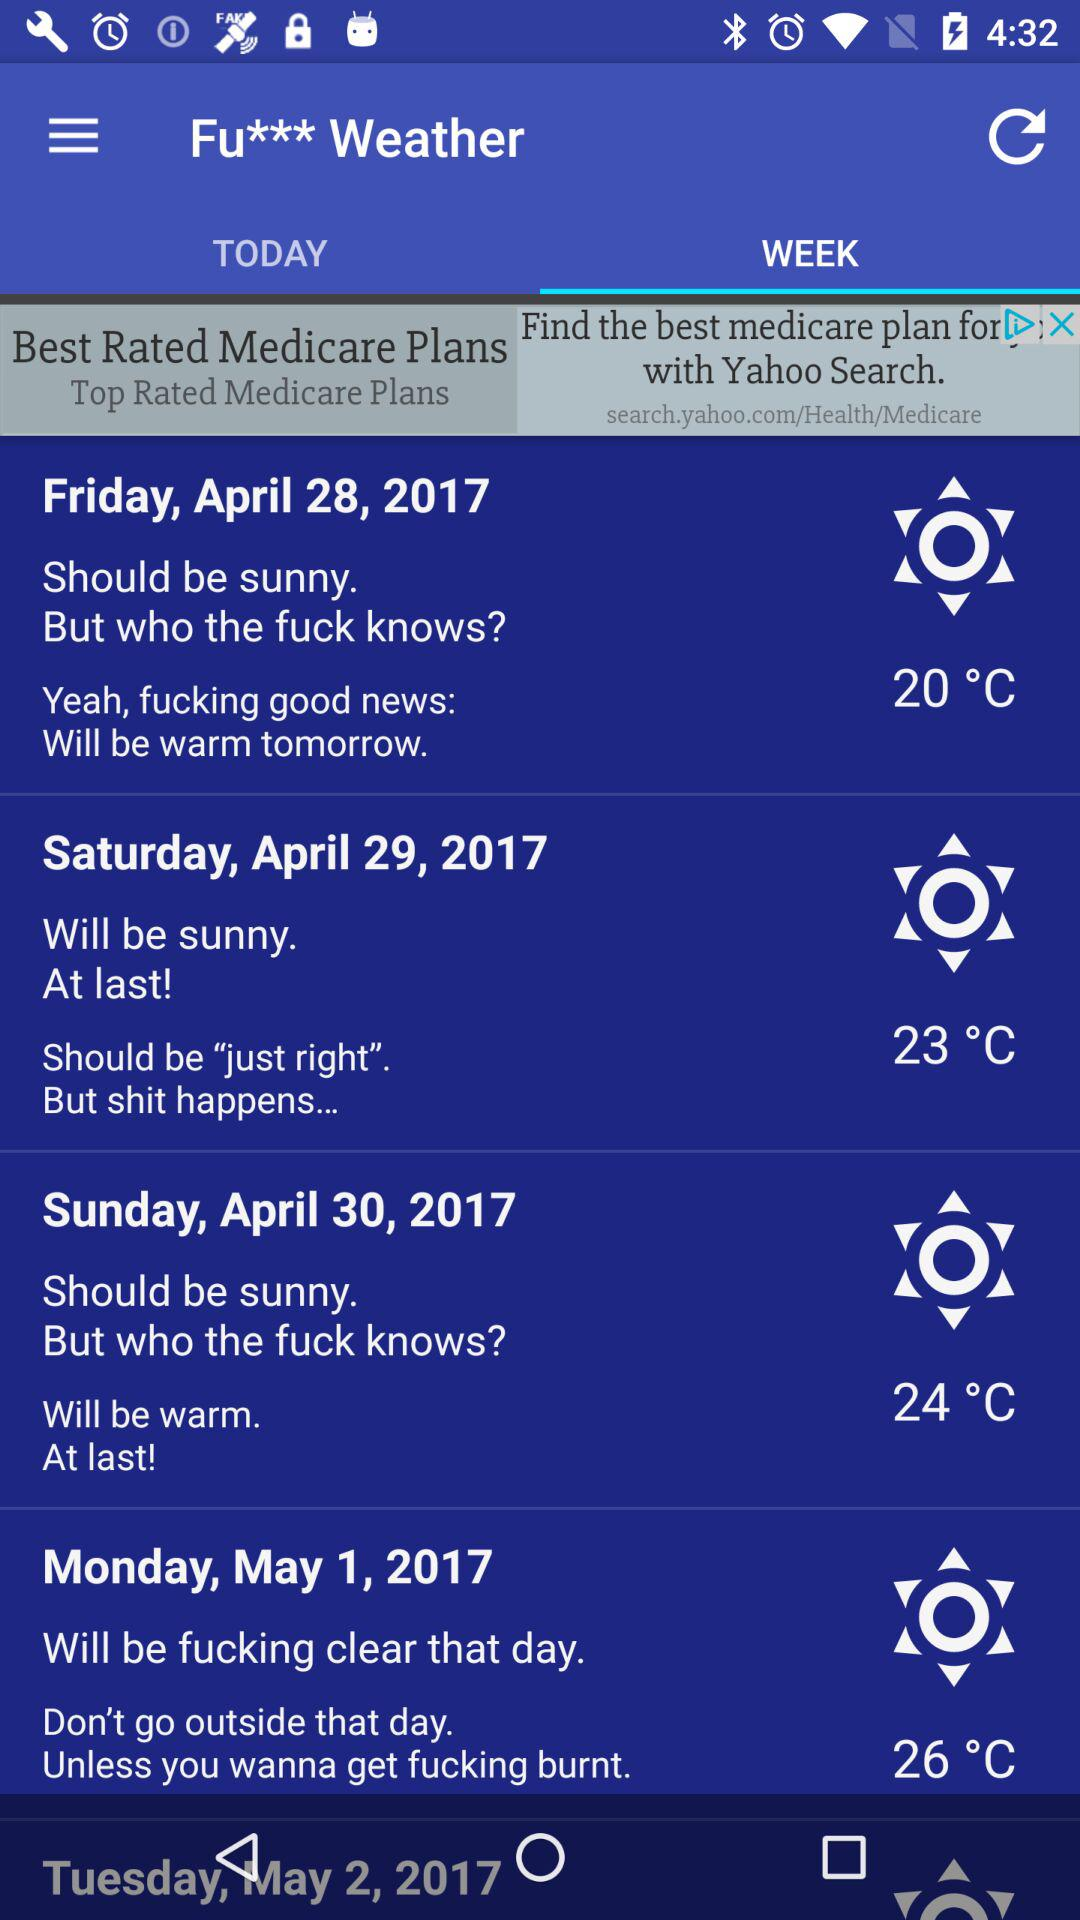What is the temperature on April 28? The temperature is 20 °C. 